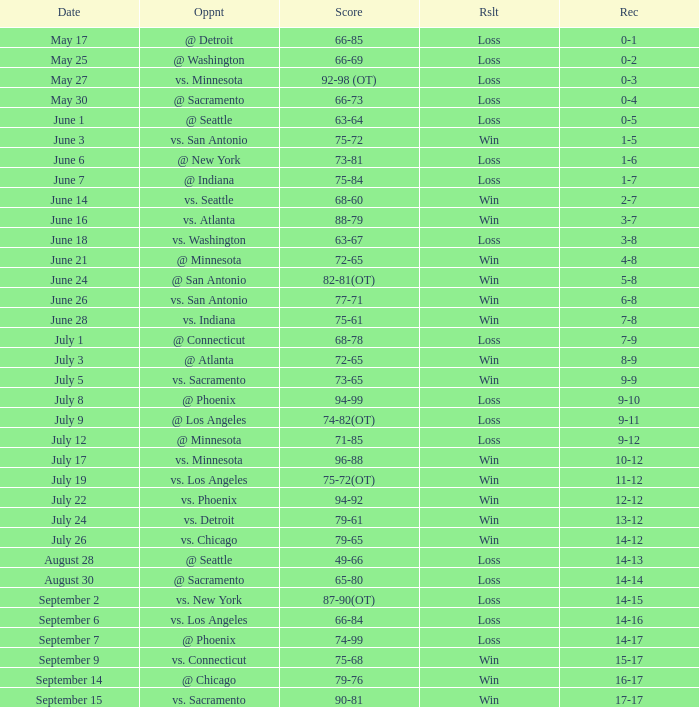What is the Date of the game with a Loss and Record of 7-9? July 1. 